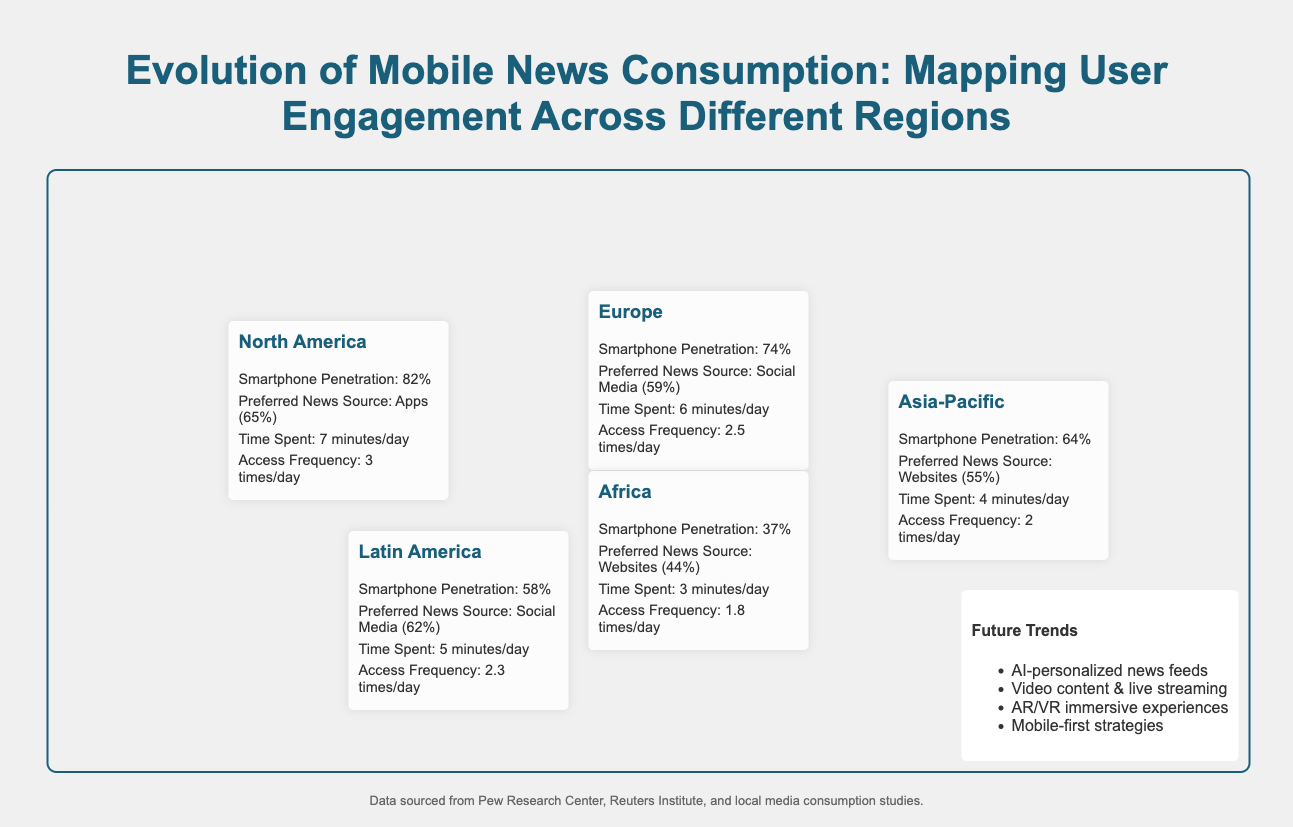What is the smartphone penetration in North America? The smartphone penetration in North America is listed in the document as 82%.
Answer: 82% What is the preferred news source in Europe? The document states that the preferred news source in Europe is Social Media (59%).
Answer: Social Media (59%) How many minutes per day do people in Asia-Pacific spend on mobile news? The time spent on mobile news in Asia-Pacific is specified in the document as 4 minutes/day.
Answer: 4 minutes/day What is the access frequency of mobile news in Africa? The document indicates that the access frequency in Africa is 1.8 times/day.
Answer: 1.8 times/day Which region has the highest smartphone penetration? By comparing the smartphone penetration rates, North America has the highest rate at 82%.
Answer: North America What is the preferred news source in Latin America? According to the document, the preferred news source in Latin America is Social Media (62%).
Answer: Social Media (62%) How does the time spent on mobile news in Europe compare to North America? The time spent on mobile news in Europe is 6 minutes/day, while in North America it is 7 minutes/day, indicating North America spends more time.
Answer: North America spends more time Which region has the lowest smartphone penetration? The document states that Africa has the lowest smartphone penetration at 37%.
Answer: Africa What future trend includes 'AI-personalized news feeds'? This trend is listed in the legend section of the document.
Answer: AI-personalized news feeds 